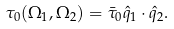Convert formula to latex. <formula><loc_0><loc_0><loc_500><loc_500>\tau _ { 0 } ( \Omega _ { 1 } , \Omega _ { 2 } ) = \bar { \tau } _ { 0 } \hat { q } _ { 1 } \cdot \hat { q } _ { 2 } .</formula> 